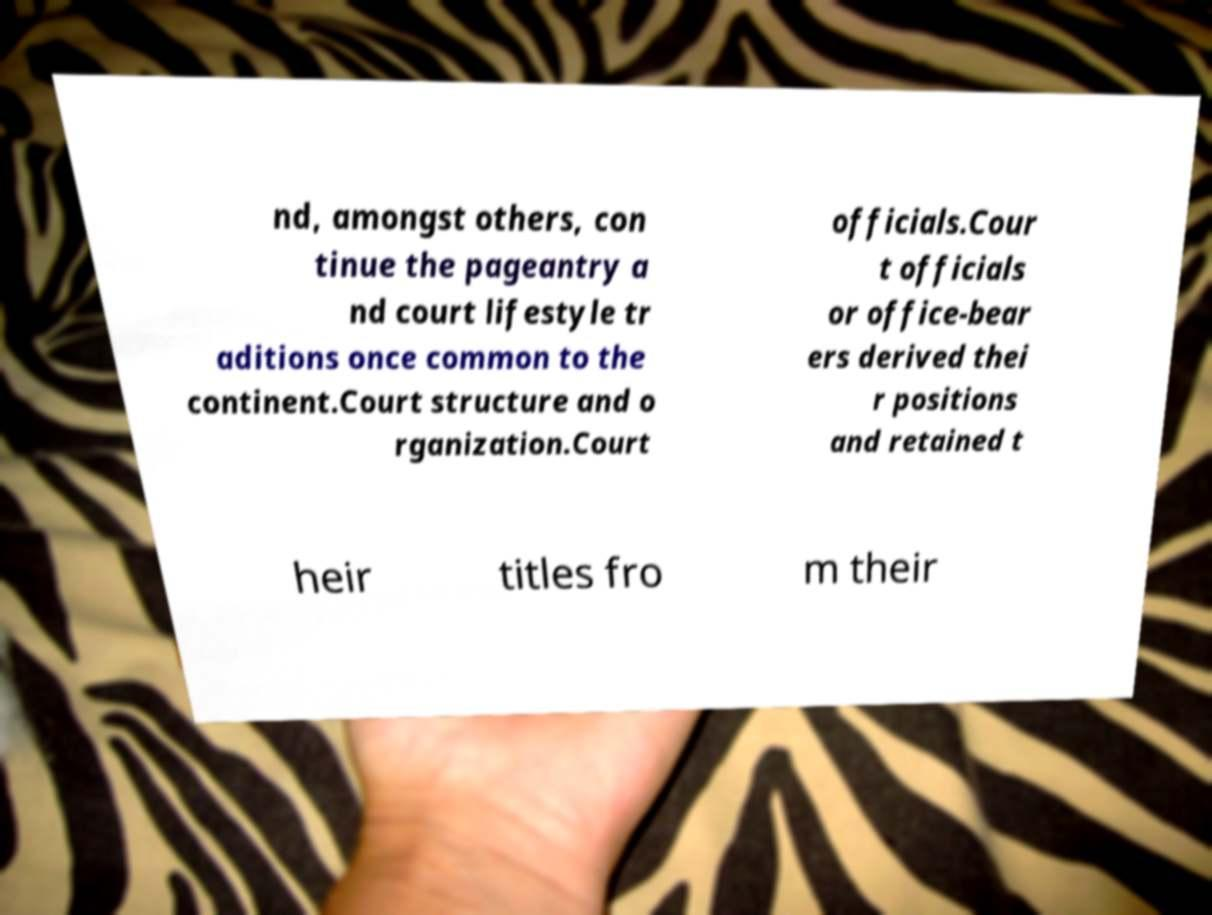What messages or text are displayed in this image? I need them in a readable, typed format. nd, amongst others, con tinue the pageantry a nd court lifestyle tr aditions once common to the continent.Court structure and o rganization.Court officials.Cour t officials or office-bear ers derived thei r positions and retained t heir titles fro m their 